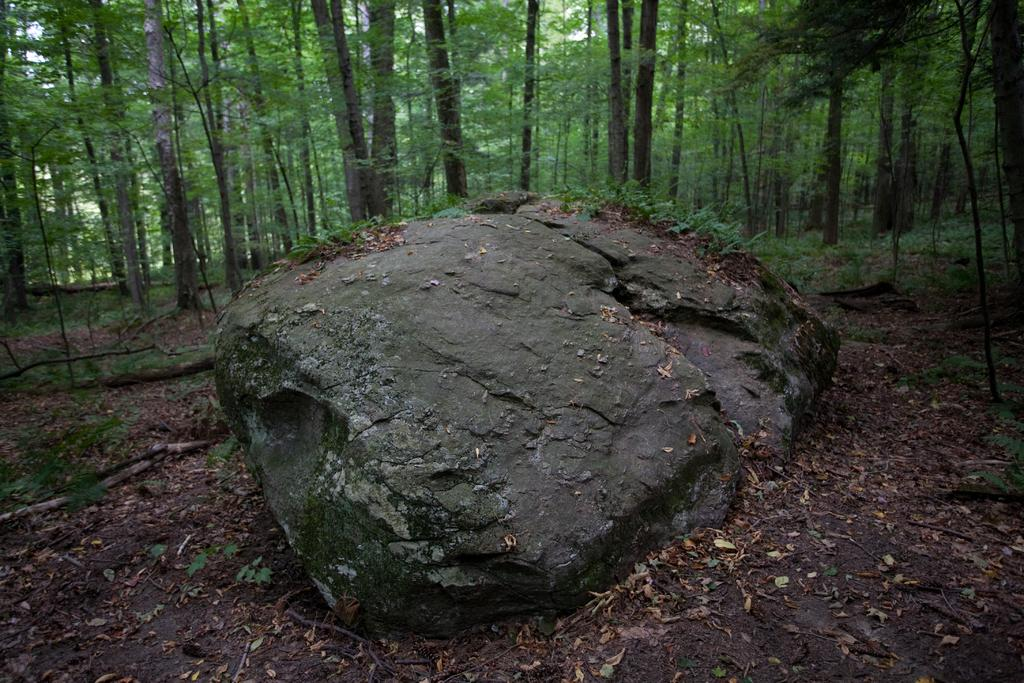What is the main feature in the forest in the image? There is a huge rock in the forest. What can be seen behind the rock in the image? There are tall trees behind the rock. What type of instrument is being played by the authority figure in the image? There is no instrument or authority figure present in the image; it only features a huge rock and tall trees in the forest. 